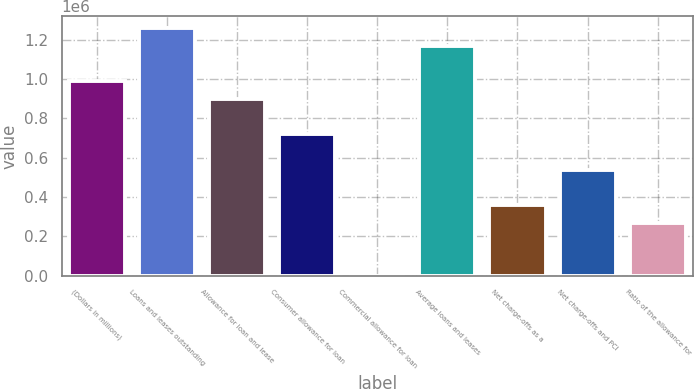Convert chart. <chart><loc_0><loc_0><loc_500><loc_500><bar_chart><fcel>(Dollars in millions)<fcel>Loans and leases outstanding<fcel>Allowance for loan and lease<fcel>Consumer allowance for loan<fcel>Commercial allowance for loan<fcel>Average loans and leases<fcel>Net charge-offs as a<fcel>Net charge-offs and PCI<fcel>Ratio of the allowance for<nl><fcel>988699<fcel>1.25834e+06<fcel>898817<fcel>719054<fcel>0.9<fcel>1.16846e+06<fcel>359527<fcel>539291<fcel>269646<nl></chart> 